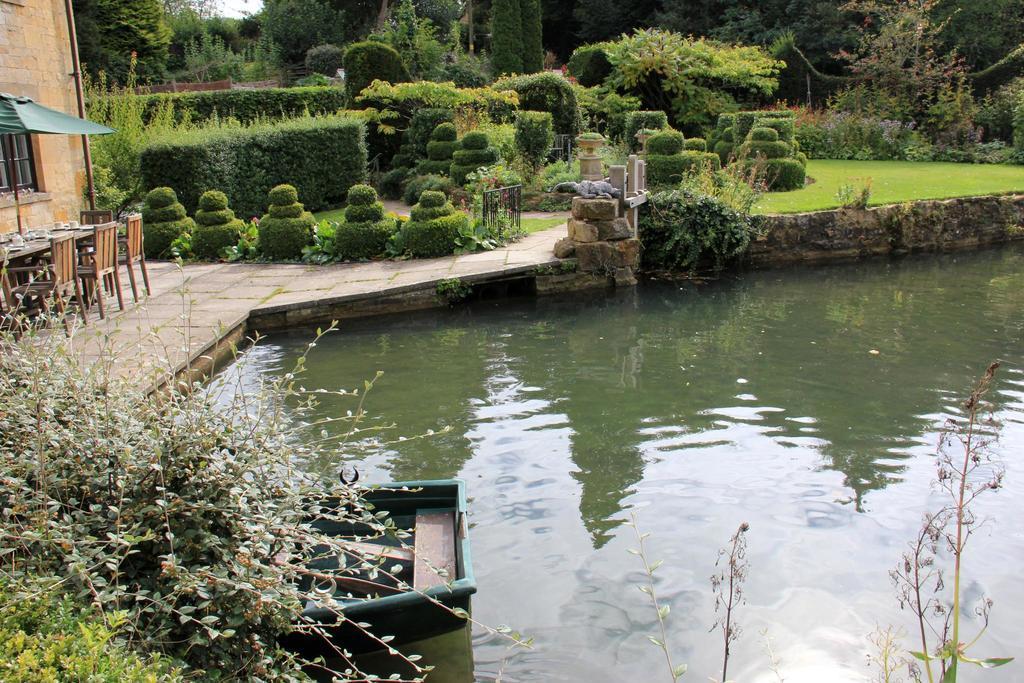Describe this image in one or two sentences. In the center of the image there is water. In the background of the image there are trees, plants, grass. To the left side of the image there is a building. There are chairs, tables. To the left side bottom of the image there are plants. 